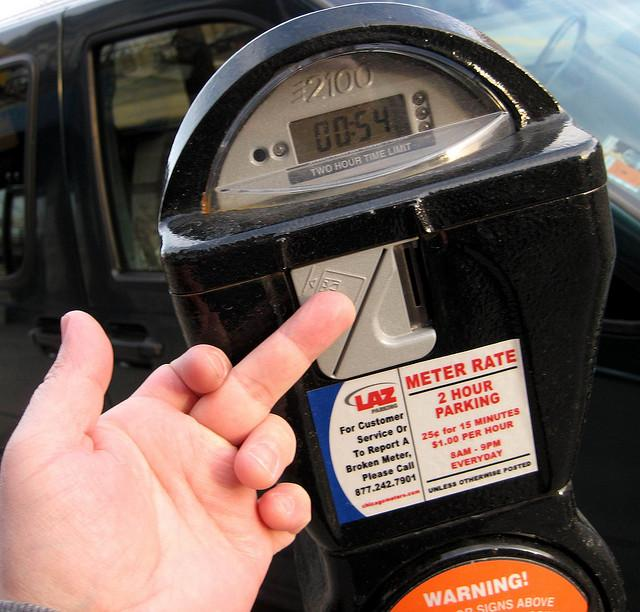What are they doing?

Choices:
A) attacking meter
B) paying meter
C) reading meter
D) expressing displeasure expressing displeasure 